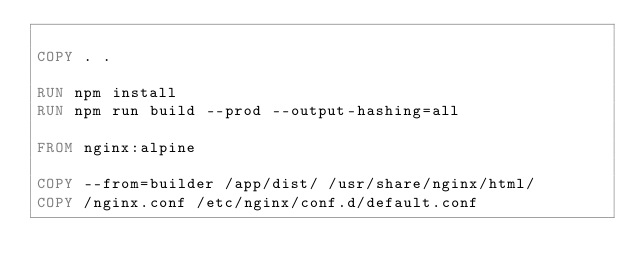Convert code to text. <code><loc_0><loc_0><loc_500><loc_500><_Dockerfile_>
COPY . .

RUN npm install
RUN npm run build --prod --output-hashing=all

FROM nginx:alpine

COPY --from=builder /app/dist/ /usr/share/nginx/html/
COPY /nginx.conf /etc/nginx/conf.d/default.conf
</code> 